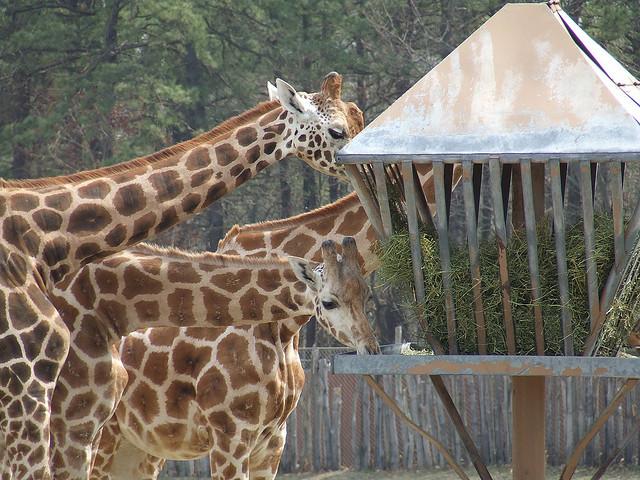What type of plant is the giraffe eating?
Concise answer only. Grass. What material is the fence?
Write a very short answer. Wood. Are these animal in captivity?
Answer briefly. Yes. How many giraffes are there?
Be succinct. 3. Are they eating?
Concise answer only. Yes. 